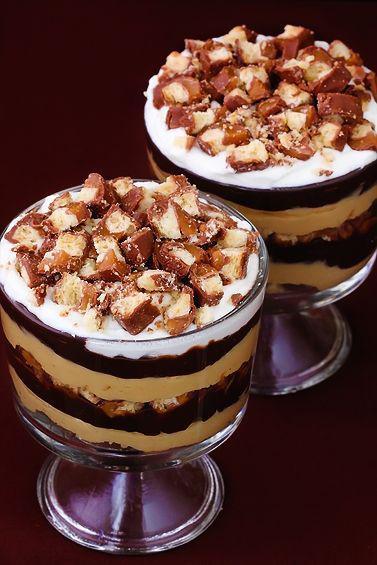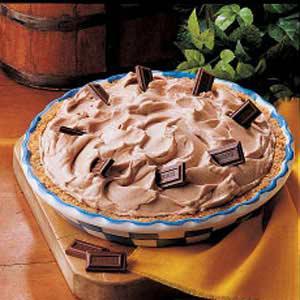The first image is the image on the left, the second image is the image on the right. Evaluate the accuracy of this statement regarding the images: "No more than one dessert is shown on each picture.". Is it true? Answer yes or no. No. 